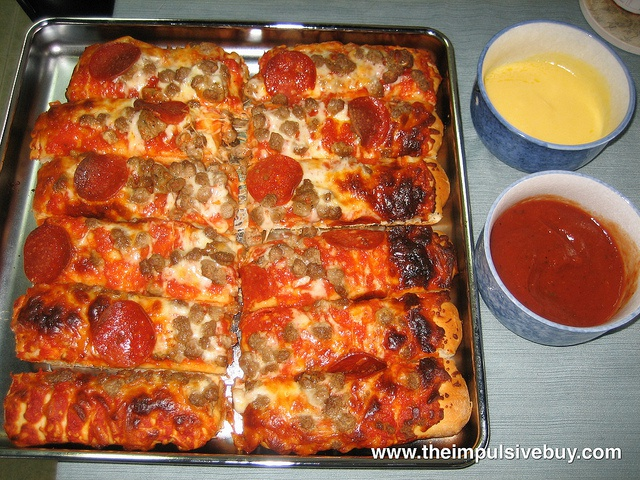Describe the objects in this image and their specific colors. I can see pizza in darkgreen, red, brown, and tan tones, bowl in darkgreen, maroon, lightgray, darkgray, and brown tones, bowl in darkgreen, gold, tan, and gray tones, and bowl in darkgreen and gray tones in this image. 